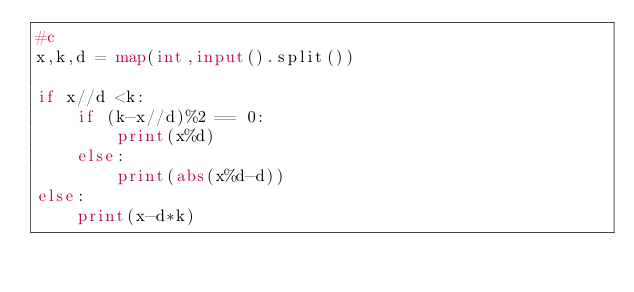<code> <loc_0><loc_0><loc_500><loc_500><_Python_>#c
x,k,d = map(int,input().split())

if x//d <k:
    if (k-x//d)%2 == 0:
        print(x%d)
    else:
        print(abs(x%d-d))
else:
    print(x-d*k)
</code> 